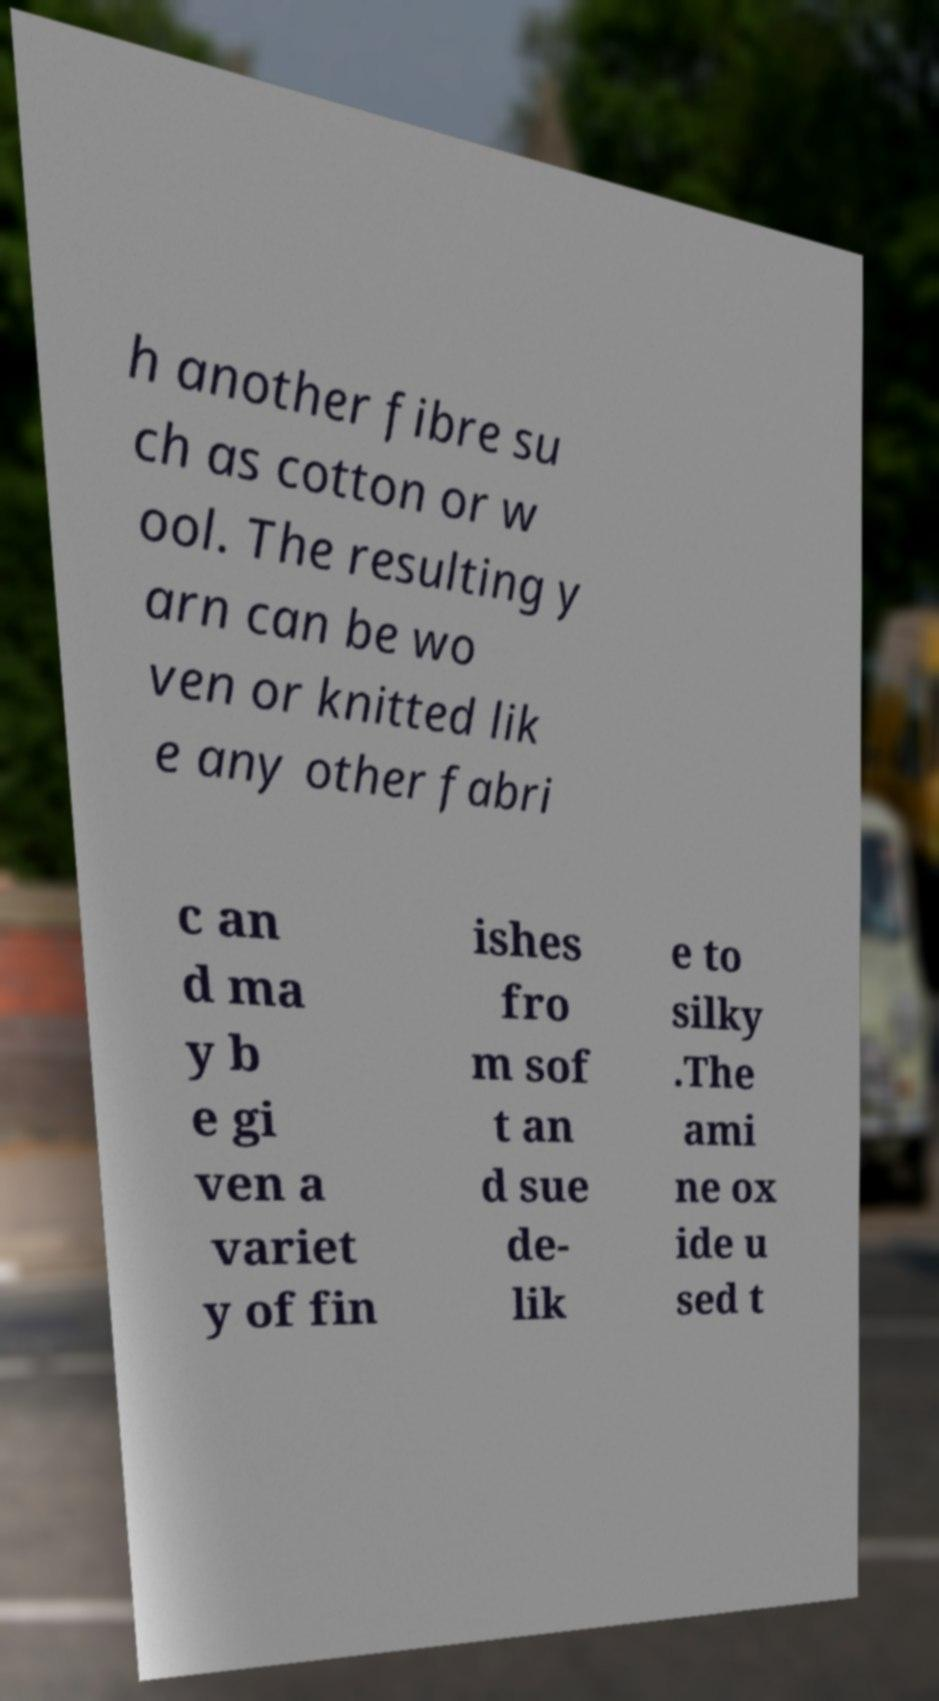Please read and relay the text visible in this image. What does it say? h another fibre su ch as cotton or w ool. The resulting y arn can be wo ven or knitted lik e any other fabri c an d ma y b e gi ven a variet y of fin ishes fro m sof t an d sue de- lik e to silky .The ami ne ox ide u sed t 